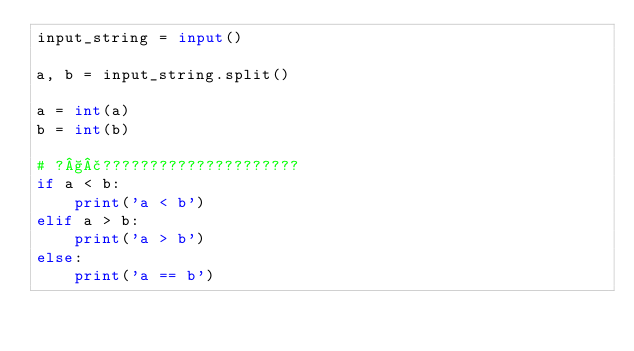Convert code to text. <code><loc_0><loc_0><loc_500><loc_500><_Python_>input_string = input()

a, b = input_string.split()

a = int(a)
b = int(b)

# ?§£?????????????????????
if a < b:
    print('a < b')
elif a > b:
    print('a > b')
else:
    print('a == b')</code> 